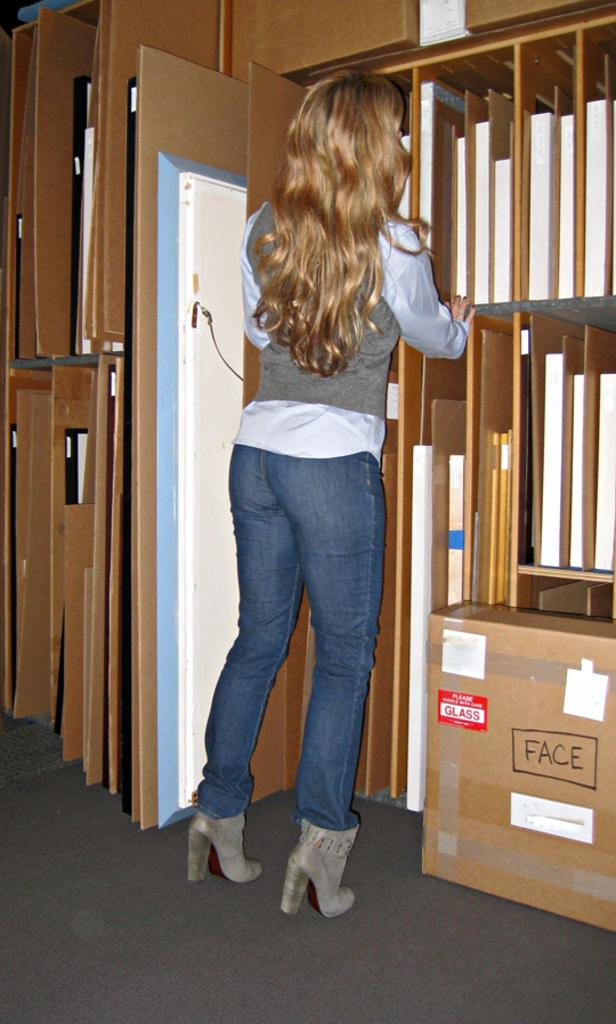Who is the main subject in the image? There is a woman in the middle of the image. What is in front of the woman? There are wooden planks in front of the woman. What object can be seen on the right side of the image? There is a box on the right side of the image. What type of bike is the visitor riding in the image? There is no bike or visitor present in the image. What kind of meat is being prepared on the wooden planks? There is no meat or cooking activity depicted in the image. 